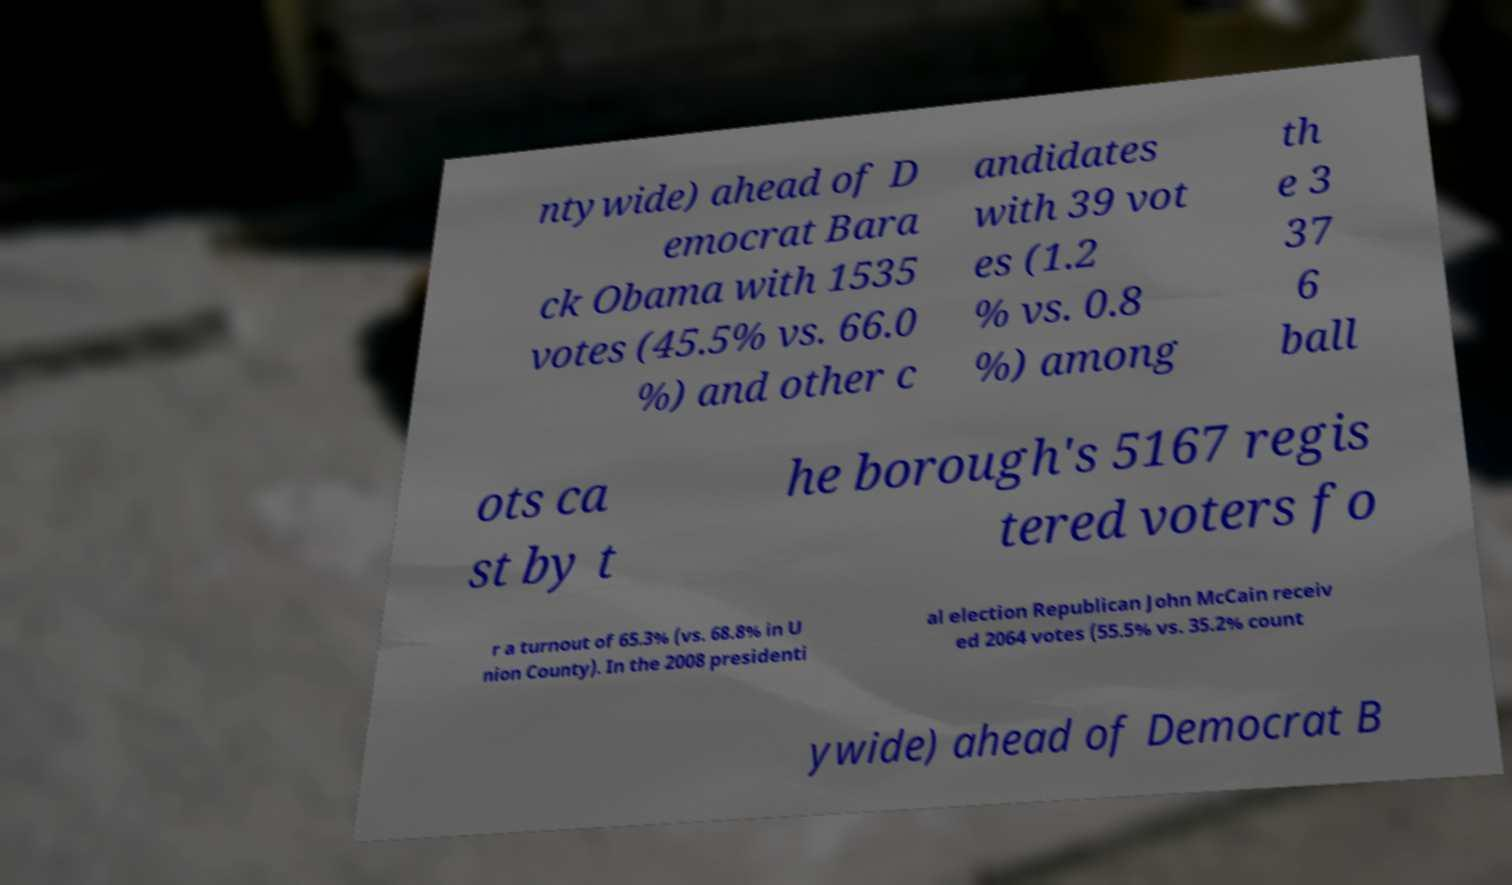Please identify and transcribe the text found in this image. ntywide) ahead of D emocrat Bara ck Obama with 1535 votes (45.5% vs. 66.0 %) and other c andidates with 39 vot es (1.2 % vs. 0.8 %) among th e 3 37 6 ball ots ca st by t he borough's 5167 regis tered voters fo r a turnout of 65.3% (vs. 68.8% in U nion County). In the 2008 presidenti al election Republican John McCain receiv ed 2064 votes (55.5% vs. 35.2% count ywide) ahead of Democrat B 